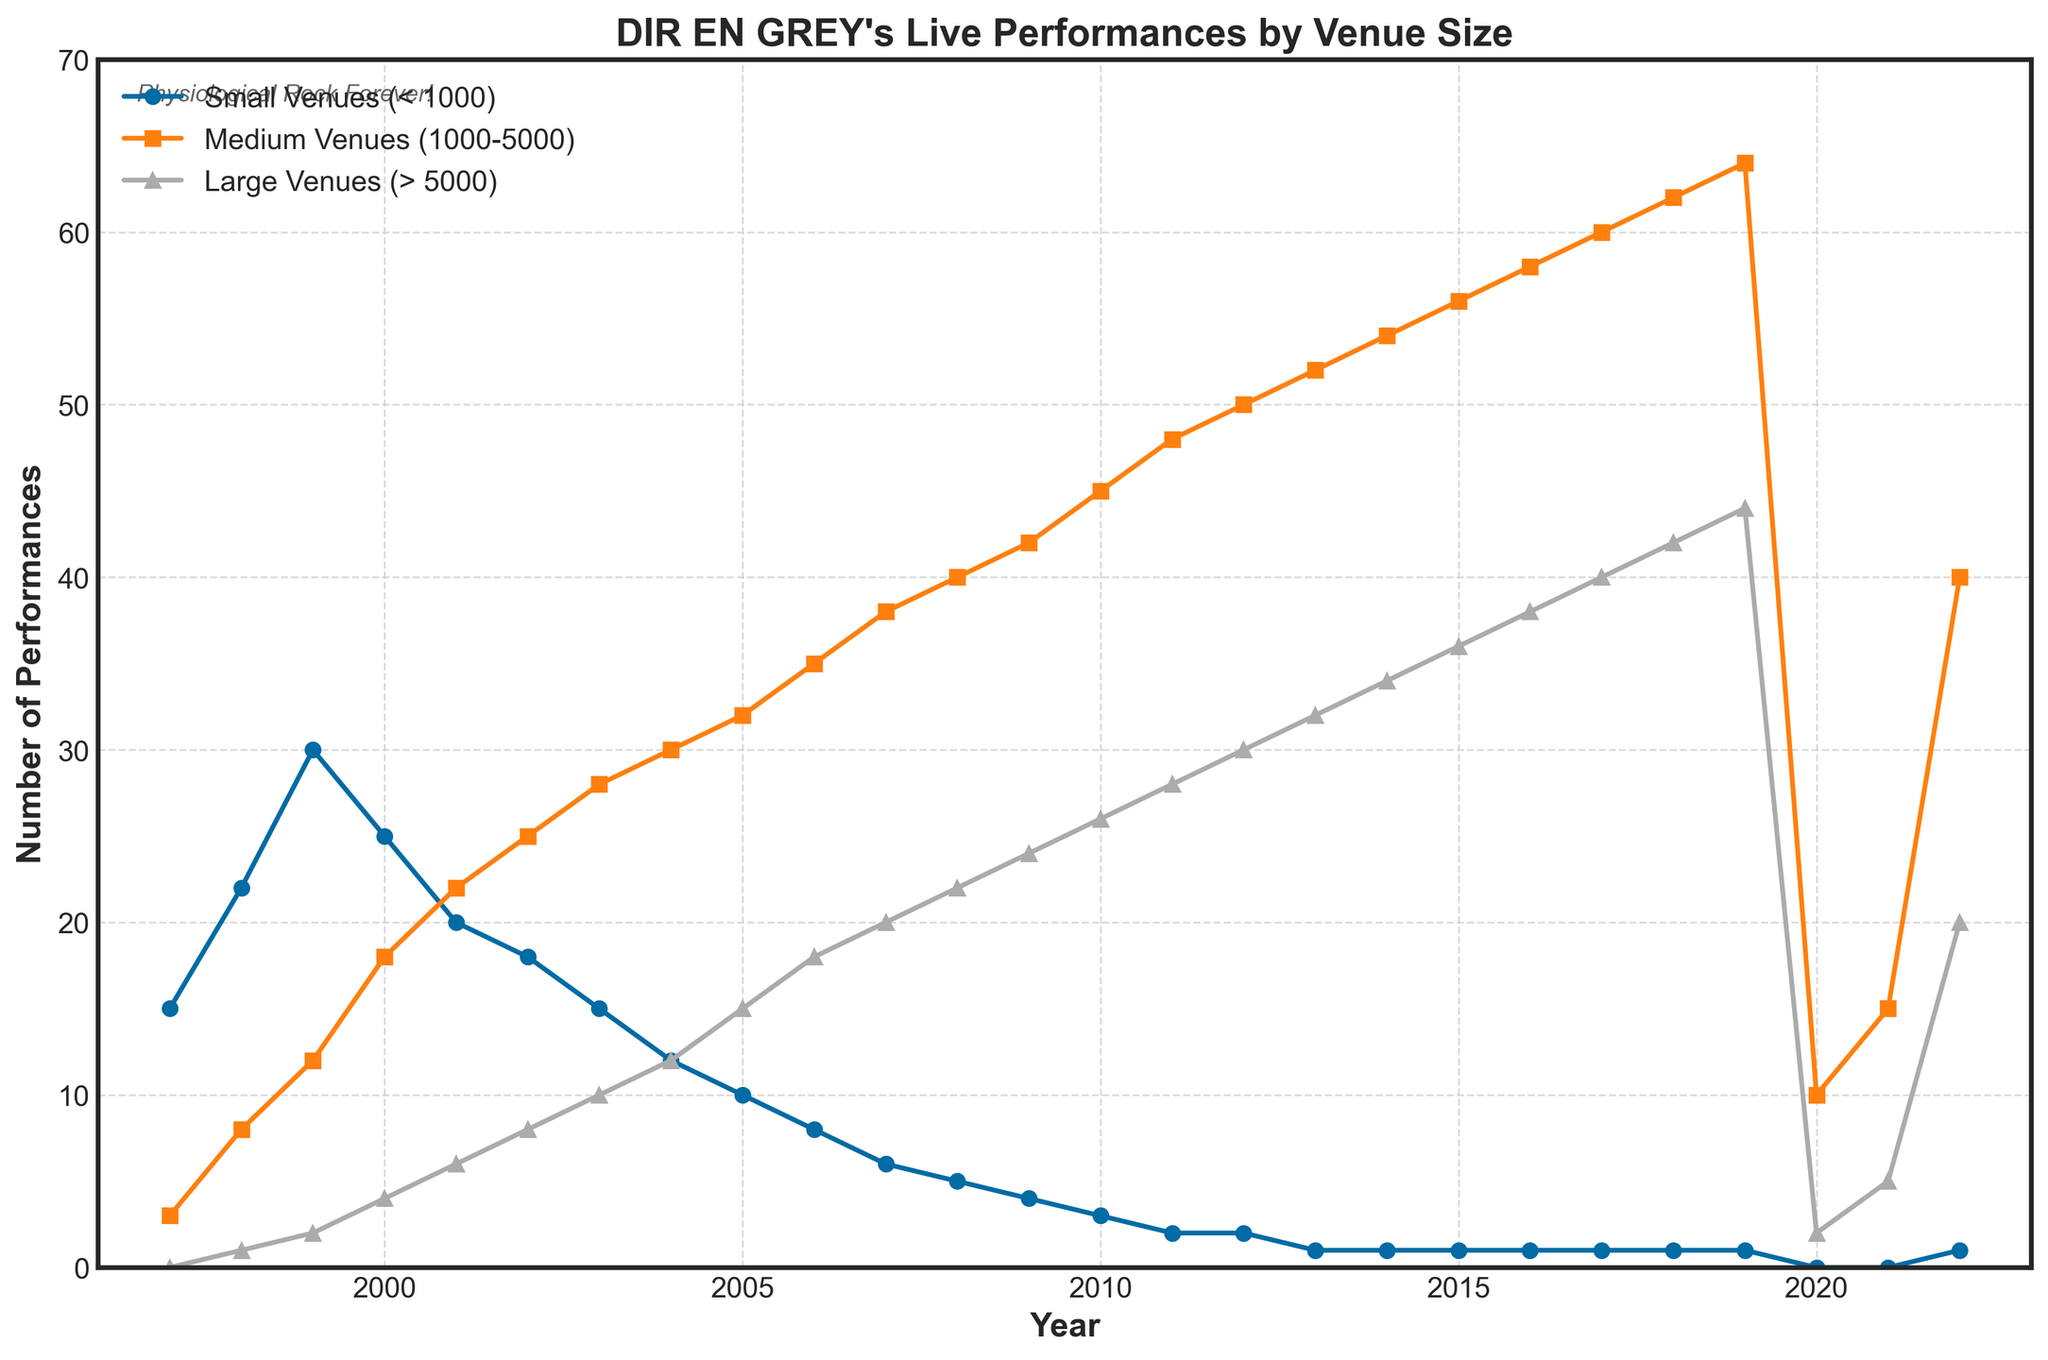What year did DIR EN GREY perform at the most small venues (< 1000)? The highest data point for small venues is 30, which occurs in 1999.
Answer: 1999 In which venue size category did DIR EN GREY's performances increase the most over the entire period? The large venues category started at 0 performances in 1997 and increased to 44 performances by 2019, giving an increase of 44, which is the highest among the categories.
Answer: Large Venues (> 5000) By how many performances did DIR EN GREY's engagements at medium venues (1000-5000) increase from 1997 to 2020? In 1997, there were 3 performances at medium venues. By 2020, this had increased to 10 performances. The difference is 10 - 3 = 7.
Answer: 7 How many performances did DIR EN GREY have in total across all venue sizes in 2005? In 2005, the number of performances were: Small (10), Medium (32), Large (15). Summing these, 10 + 32 + 15 = 57 performances in total.
Answer: 57 Did DIR EN GREY ever have more performances at large venues (> 5000) than at medium venues (1000-5000) in any year? No, the number of performances at medium venues was always higher than at large venues in every year recorded.
Answer: No How did DIR EN GREY's performances at small venues (< 1000) change between 2010 and 2011? Performances at small venues decreased from 3 in 2010 to 2 in 2011, a decrease of 1.
Answer: Decreased by 1 In which year did the number of performances at large venues (> 5000) first exceed the number of performances at small venues (< 1000)? In 2000, the number of performances at large venues (4) first exceeded those at small venues (3).
Answer: 2000 What was the ratio of performances at small venues (< 1000) to those at large venues (> 5000) in 2015? In 2015, there were 1 performance at small venues and 36 at large venues. The ratio is 1:36.
Answer: 1:36 By how much did the total number of performances decrease in 2020 compared to 2019? In 2019, the total performances were Small (1), Medium (64), Large (44) = 1 + 64 + 44 = 109. In 2020, the totals were Small (0), Medium (10), Large (2) = 0 + 10 + 2 = 12. The decrease is 109 - 12 = 97.
Answer: 97 What is the trend in the number of performances at small venues (< 1000) from 1997 onwards? The number of performances at small venues generally decreases over time from 15 in 1997 to 1 in recent years.
Answer: Decreasing 